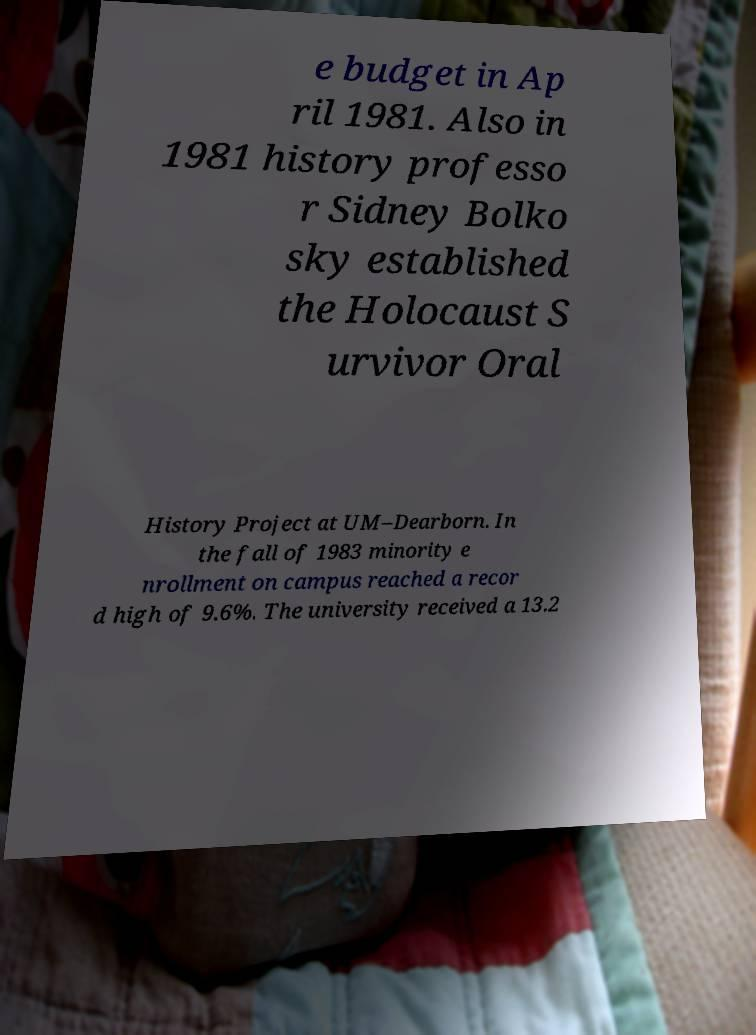Can you read and provide the text displayed in the image?This photo seems to have some interesting text. Can you extract and type it out for me? e budget in Ap ril 1981. Also in 1981 history professo r Sidney Bolko sky established the Holocaust S urvivor Oral History Project at UM–Dearborn. In the fall of 1983 minority e nrollment on campus reached a recor d high of 9.6%. The university received a 13.2 